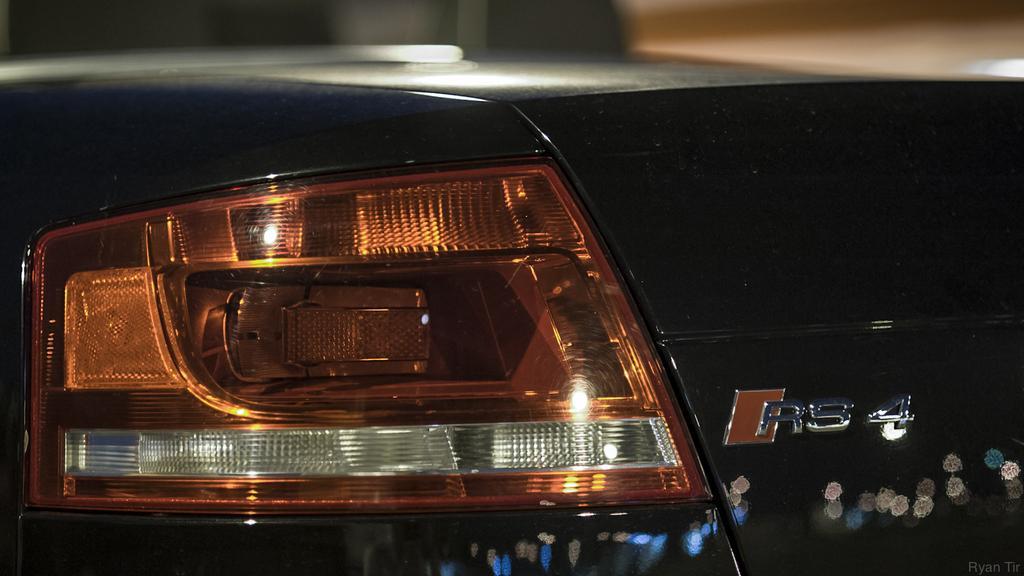Could you give a brief overview of what you see in this image? In this picture, we can see back part of the car highlighted, and we see the blurred background, we can see some light reflection on the car. 